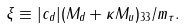<formula> <loc_0><loc_0><loc_500><loc_500>\xi \equiv | c _ { d } | ( M _ { d } + \kappa M _ { u } ) _ { 3 3 } / m _ { \tau } .</formula> 